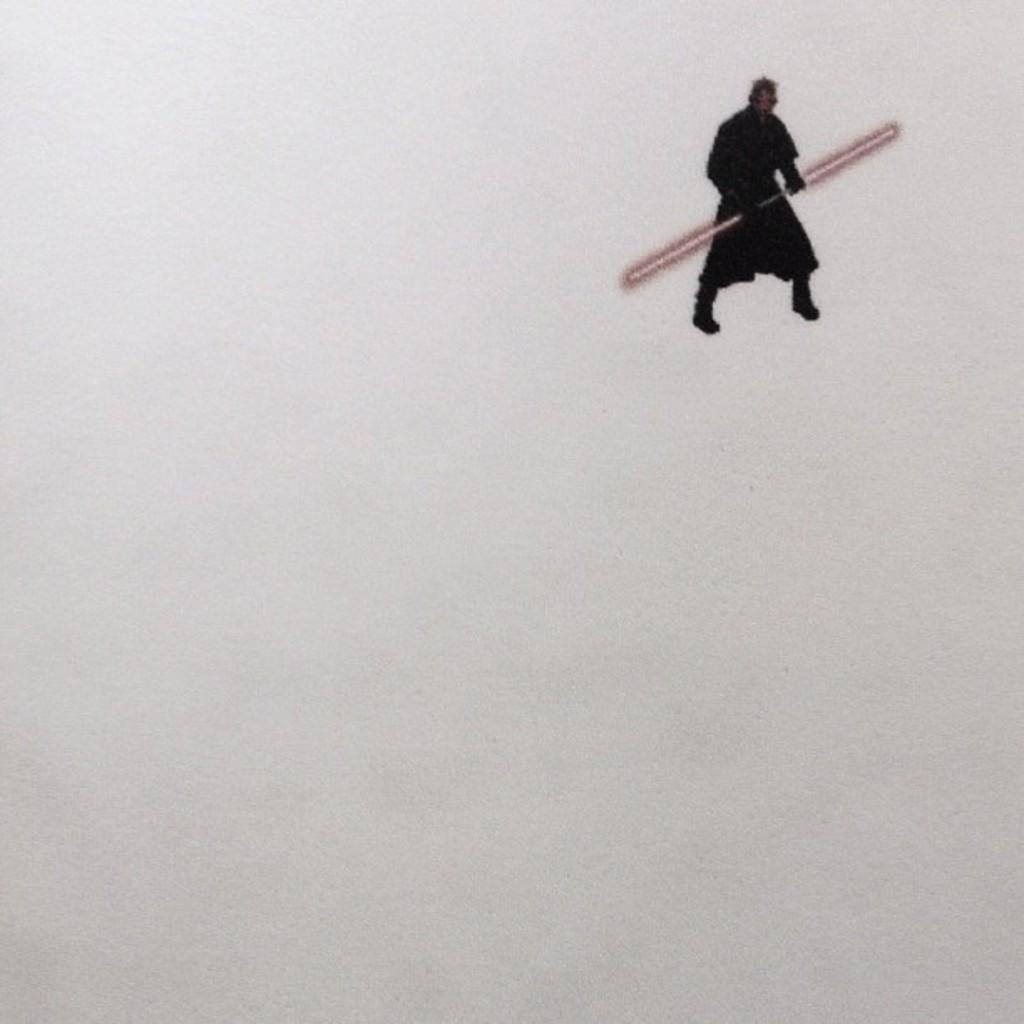What is the main subject of the image? There is a person in the image. What is the person holding in the image? The person is holding a red color thing. What is the color of the background in the image? The background of the image is white. What type of flame can be seen coming from the person's hand in the image? There is no flame present in the image; the person is holding a red color thing. What type of legal advice is the person providing in the image? There is no indication in the image that the person is providing legal advice or acting as a lawyer. 